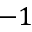Convert formula to latex. <formula><loc_0><loc_0><loc_500><loc_500>- 1</formula> 